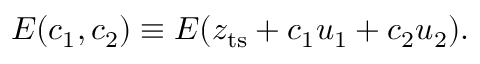<formula> <loc_0><loc_0><loc_500><loc_500>E ( c _ { 1 } , c _ { 2 } ) \equiv E ( z _ { t s } + c _ { 1 } u _ { 1 } + c _ { 2 } u _ { 2 } ) .</formula> 